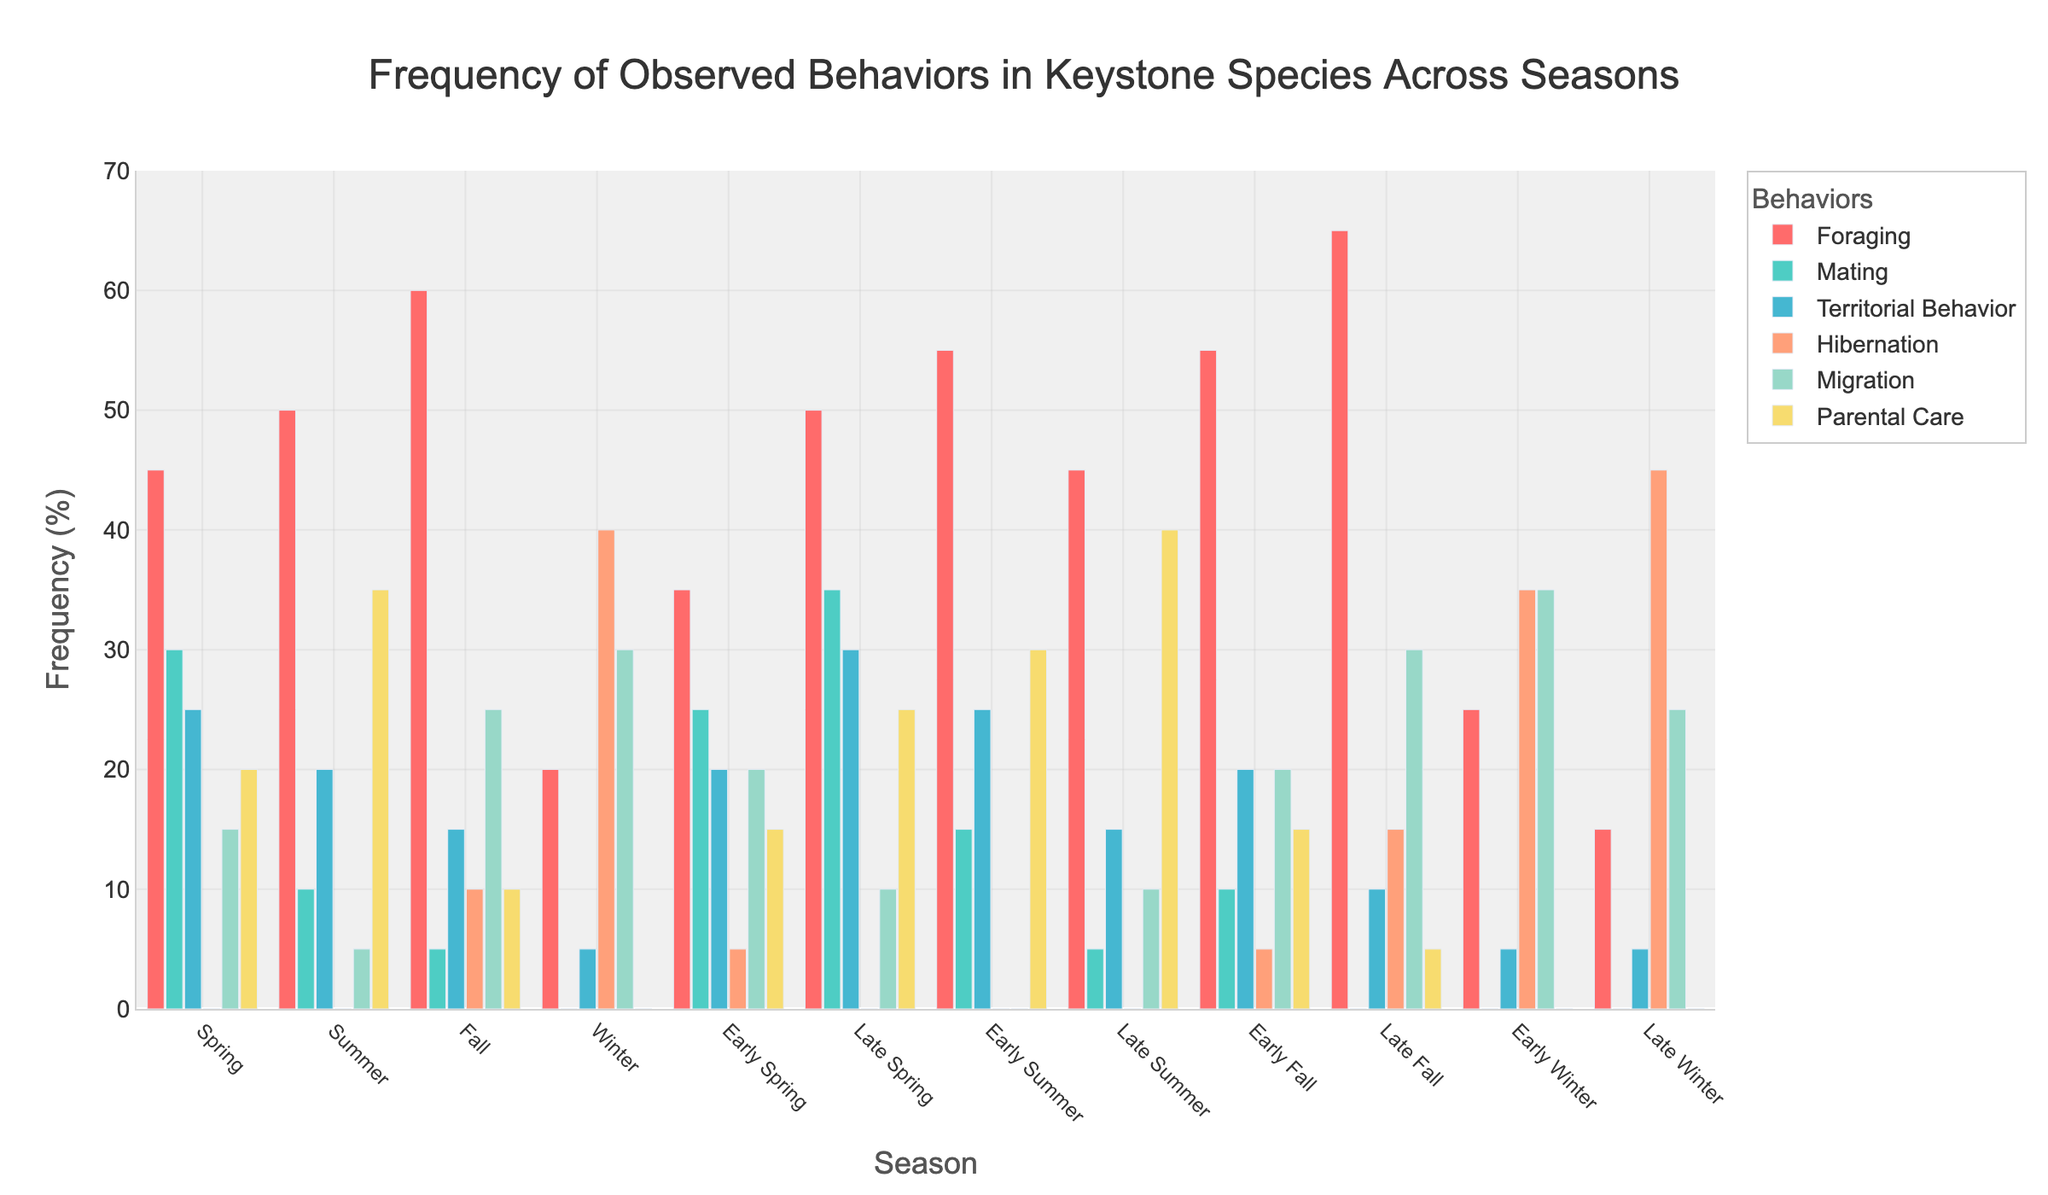Which season has the highest frequency of foraging behavior? To find the season with the highest frequency of foraging, look at the tallest bar in the foraging section. Late Fall has the highest bar with a frequency of 65.
Answer: Late Fall What is the total frequency of mating behavior observed across Fall and Winter? Add the frequencies of mating behavior in Early Fall, Late Fall, Early Winter, and Late Winter: 10 + 0 + 0 + 0 = 10.
Answer: 10 Which season shows the lowest frequency of territorial behavior? Look at the smallest bar in the territorial behavior sections across all seasons. Both Winter, Early Winter, and Late Winter have the lowest frequency of 5.
Answer: Winter, Early Winter, Late Winter Are there any seasons where hibernation behavior was not observed at all? Check the bars under hibernation for any with a height of 0. These seasons are Spring, Summer, Late Spring, Early Summer, Late Summer.
Answer: Spring, Summer, Late Spring, Early Summer, Late Summer Compare the frequency of parental care between Early Spring and Early Summer. Which one is higher? Look at the height of the bars for parental care in Early Spring and Early Summer. Early Summer's bar (30) is taller than Early Spring's (15).
Answer: Early Summer In which season is migration observed the least and the most? Check the heights of the migration bars across all seasons. The lowest observed migration is in Early Summer (0) and the highest is in Early Winter (35).
Answer: Least: Early Summer, Most: Early Winter Calculate the average frequency of foraging behavior across all seasons. Sum the foraging frequencies and then divide by the number of seasons. (45 + 50 + 60 + 20 + 35 + 50 + 55 + 45 + 55 + 65 + 25 + 15)/12 = 475/12 ≈ 39.58.
Answer: 39.58 Which season has the highest combined frequency of foraging and mating behaviors? Add the values of foraging and mating behaviors for each season, and identify the highest sum. Late Spring has the highest combined frequency of 50 + 35 = 85.
Answer: Late Spring Is there any season where territorial behavior was observed more frequently than foraging behavior? Compare the heights of the bars for territorial and foraging behaviors in each season. There are no seasons where territorial behavior is observed more than foraging.
Answer: No How does the frequency of hibernation during Early Winter compare to Late Winter? Look at the bars for hibernation in Early Winter (35) and Late Winter (45). The frequency in Late Winter is higher.
Answer: Late Winter 